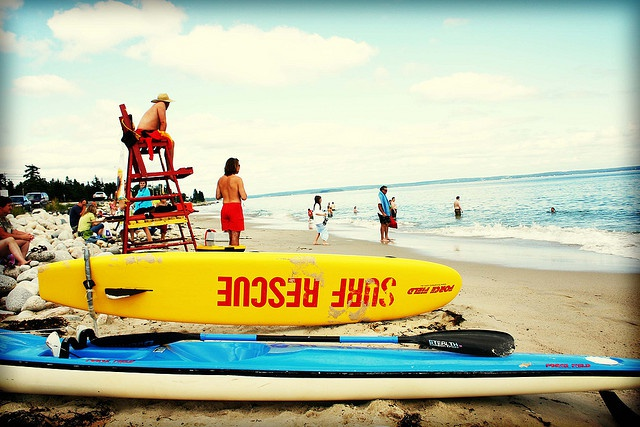Describe the objects in this image and their specific colors. I can see boat in gray, khaki, lightblue, black, and beige tones, surfboard in gray, gold, orange, and red tones, people in gray, ivory, brown, tan, and red tones, people in gray, red, black, and orange tones, and chair in gray, black, brown, maroon, and ivory tones in this image. 